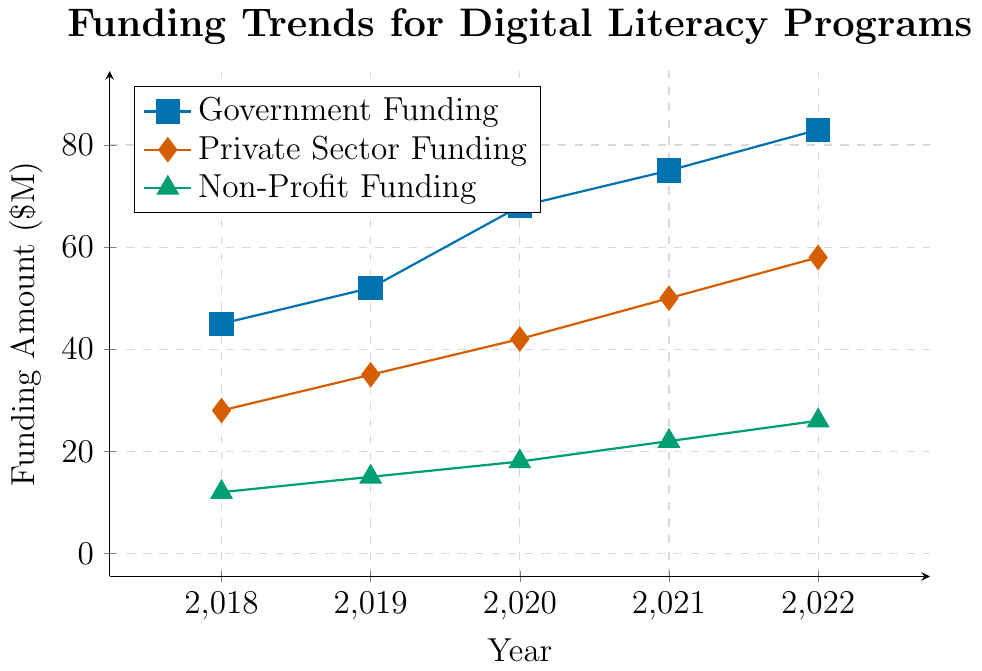What is the trend of Government Funding over the last 5 years? The Government Funding shows a consistent increase each year. From 45 million in 2018, it rises to 83 million in 2022, indicating strong upward growth.
Answer: Increasing Compare the funding amounts of Private Sector and Non-Profit in 2020. Which one is higher? In 2020, Private Sector Funding is 42 million while Non-Profit Funding is 18 million. Comparing these values, we observe that Private Sector Funding is higher than Non-Profit Funding.
Answer: Private Sector What is the total funding from all sources in 2021? To find the total funding in 2021, add the Government Funding (75 million), Private Sector Funding (50 million), and Non-Profit Funding (22 million). The total is 75 + 50 + 22 = 147 million.
Answer: 147 million How did Non-Profit Funding change from 2018 to 2022? The Non-Profit Funding in 2018 was 12 million and increased to 26 million in 2022. This is a change of 26 - 12 = 14 million.
Answer: Increased by 14 million In which year did Government Funding see the largest increase compared to the previous year? By calculating the year-over-year increases, we find: 2019-2018 (52-45=7), 2020-2019 (68-52=16), 2021-2020 (75-68=7), and 2022-2021 (83-75=8). The largest increase occurred from 2019 to 2020.
Answer: From 2019 to 2020 What is the average funding amount from Private Sector over the 5 years? Sum the Private Sector Funding for the 5 years (28 + 35 + 42 + 50 + 58) = 213 million and divide by 5. The average funding amount is 213 / 5 = 42.6 million.
Answer: 42.6 million Compare the colors used for each funding source in the chart. The Government Funding is represented by blue, Private Sector Funding by red, and Non-Profit Funding by green. These colors distinguish each funding source clearly.
Answer: Blue (Government), Red (Private Sector), Green (Non-Profit) Which funding source showed the smallest increase over the 5 years? By calculating the increase for each source: Government (83-45=38), Private Sector (58-28=30), Non-Profit (26-12=14). The smallest increase is for Non-Profit Funding.
Answer: Non-Profit What is the proportion of Government Funding in 2022 relative to the total funding in 2022? The Government Funding in 2022 is 83 million. Total funding that year is (83 + 58 + 26) = 167 million. The proportion is (83 / 167) ≈ 0.497, or approximately 49.7%.
Answer: Approximately 49.7% 